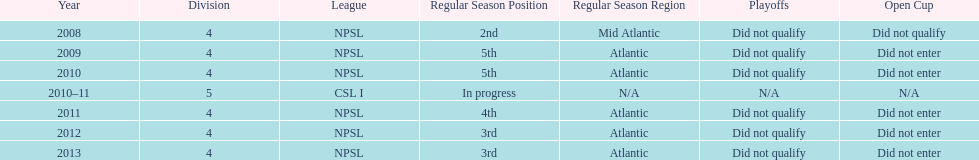What is the only year that is n/a? 2010-11. 